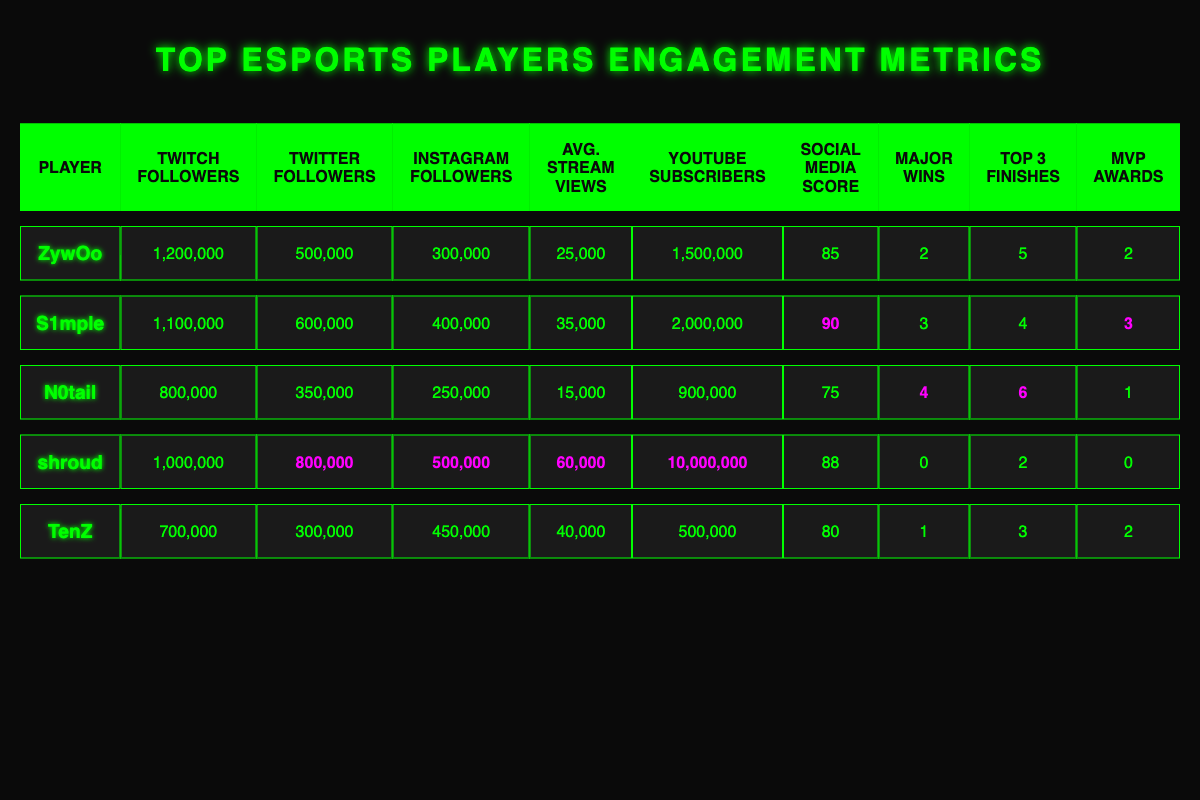What is the average number of Twitch followers among all players? To find the average, we need to sum the Twitch followers of all players: 1,200,000 + 1,100,000 + 800,000 + 1,000,000 + 700,000 = 4,800,000. Then, we divide this sum by the number of players (5). Thus, 4,800,000 / 5 = 960,000.
Answer: 960,000 Which player has the highest average views per stream? By examining the "Avg. Stream Views" column, we see that shroud has the highest value at 60,000 views per stream.
Answer: shroud How many major wins does N0tail have? Looking at the “Major Wins” column for N0tail, we see the value is 4.
Answer: 4 Does S1mple have more Instagram followers than ZywOo? Checking the Instagram followers, S1mple has 400,000 while ZywOo has 300,000. Since 400,000 is greater than 300,000, the answer is yes.
Answer: Yes What is the total number of Twitter followers for all the players combined? We add the Twitter followers: 500,000 (ZywOo) + 600,000 (S1mple) + 350,000 (N0tail) + 800,000 (shroud) + 300,000 (TenZ) = 2,550,000.
Answer: 2,550,000 Who has the lowest social media activity score? By checking the "Social Media Score" values, we see that N0tail has the lowest score, which is 75.
Answer: N0tail If we combine the top 3 finishes of all players, what is the total? We sum the "Top 3 Finishes": 5 (ZywOo) + 4 (S1mple) + 6 (N0tail) + 2 (shroud) + 3 (TenZ) = 20.
Answer: 20 Which player has a higher social media activity score: shroud or TenZ? shroud has a score of 88, while TenZ has a score of 80. Since 88 is greater than 80, shroud has the higher score.
Answer: shroud What would be the average number of YouTube subscribers among the players? The total number of YouTube subscribers is calculated as follows: 1,500,000 (ZywOo) + 2,000,000 (S1mple) + 900,000 (N0tail) + 10,000,000 (shroud) + 500,000 (TenZ) = 15,900,000. We divide this by 5 players, resulting in 15,900,000 / 5 = 3,180,000.
Answer: 3,180,000 If we compare the number of MVP awards, who has more: N0tail or TenZ? N0tail has 1 MVP award while TenZ has 2. Since 2 is greater than 1, TenZ has more MVP awards.
Answer: TenZ 